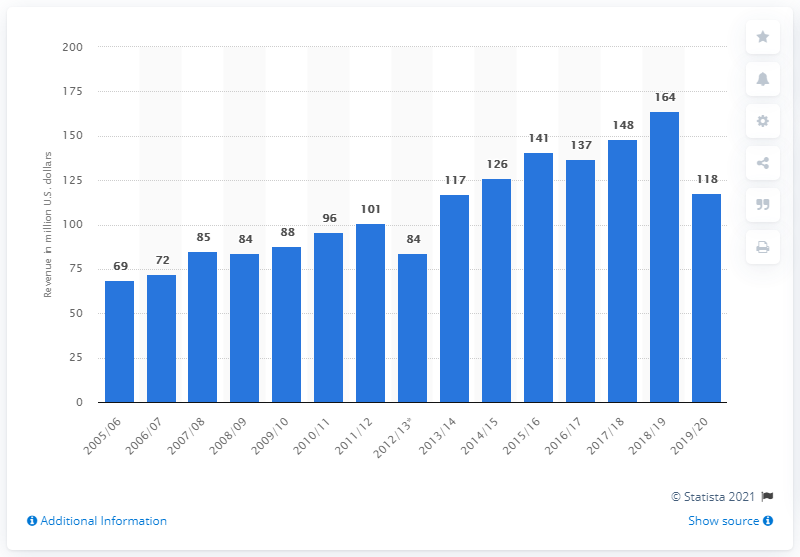Identify some key points in this picture. The San Jose Sharks earned approximately 118 million US dollars in the 2019/2020 season. 